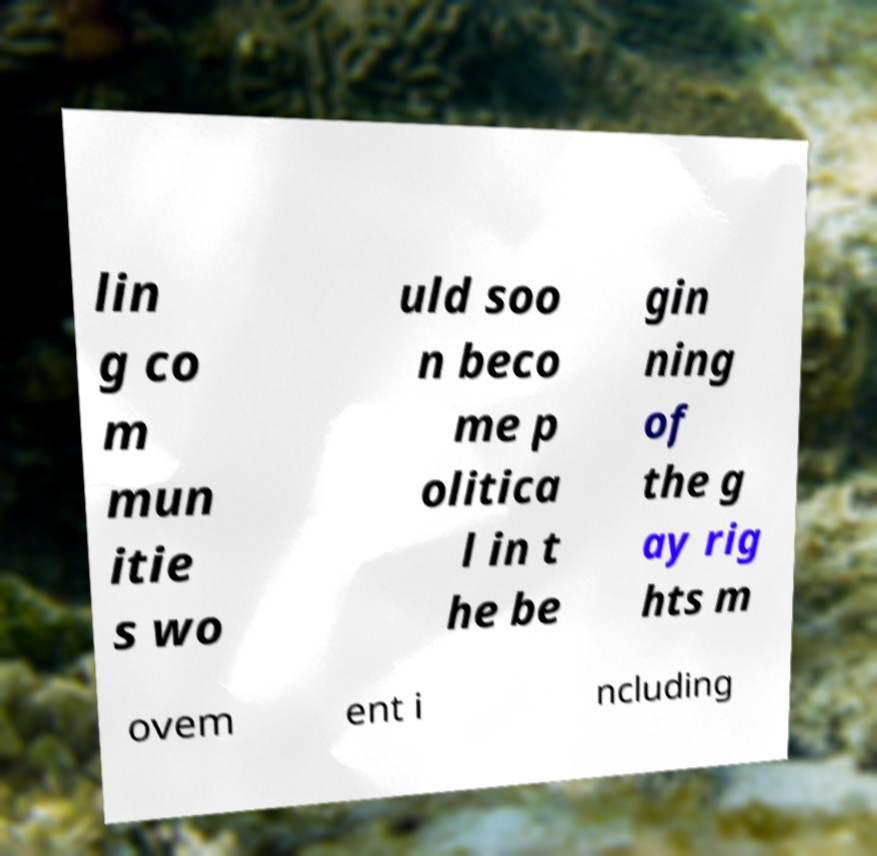For documentation purposes, I need the text within this image transcribed. Could you provide that? lin g co m mun itie s wo uld soo n beco me p olitica l in t he be gin ning of the g ay rig hts m ovem ent i ncluding 